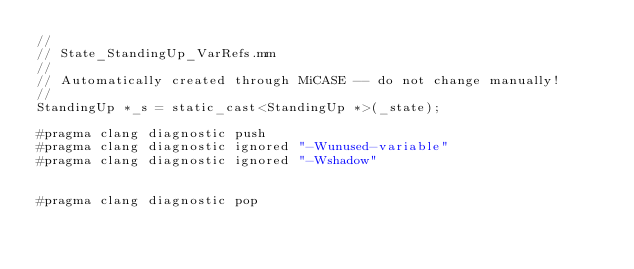<code> <loc_0><loc_0><loc_500><loc_500><_ObjectiveC_>//
// State_StandingUp_VarRefs.mm
//
// Automatically created through MiCASE -- do not change manually!
//
StandingUp *_s = static_cast<StandingUp *>(_state);

#pragma clang diagnostic push
#pragma clang diagnostic ignored "-Wunused-variable"
#pragma clang diagnostic ignored "-Wshadow"


#pragma clang diagnostic pop
</code> 